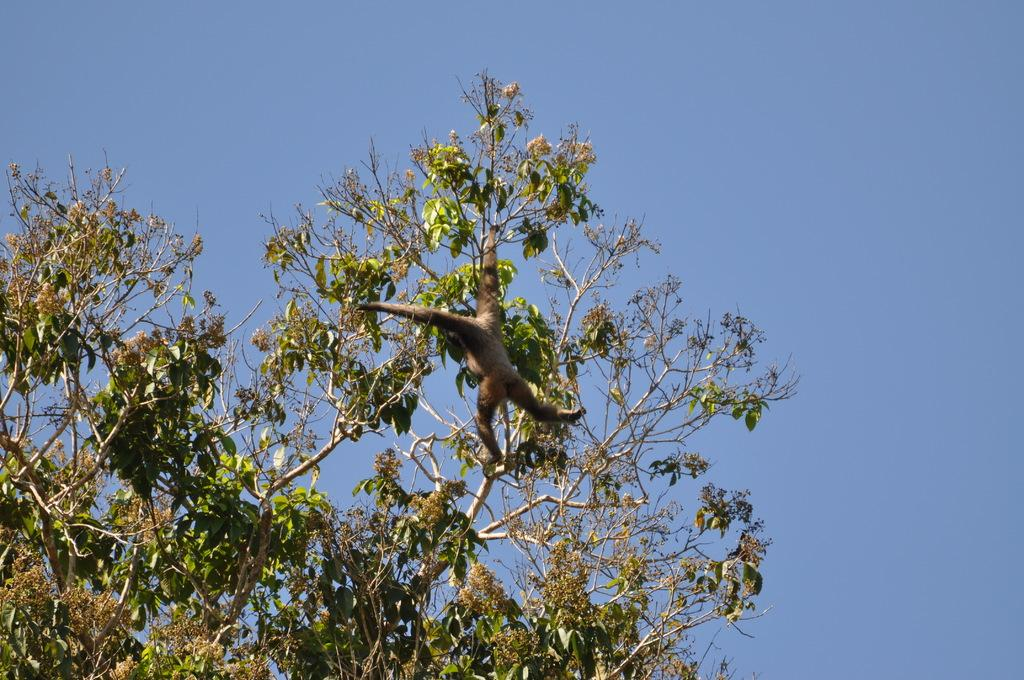What animal is present in the image? There is a monkey in the image. Where is the monkey located? The monkey is on a tree. What can be seen in the background of the image? There is sky visible in the background of the image. What color is the monkey's eye in the image? The image does not provide enough detail to determine the color of the monkey's eye. 